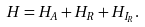Convert formula to latex. <formula><loc_0><loc_0><loc_500><loc_500>H = H _ { A } + H _ { R } + H _ { I _ { R } } .</formula> 